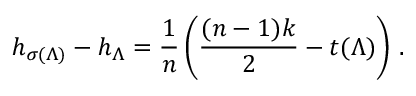Convert formula to latex. <formula><loc_0><loc_0><loc_500><loc_500>h _ { \sigma ( \Lambda ) } - h _ { \Lambda } = \frac { 1 } { n } \left ( \frac { ( n - 1 ) k } 2 - t ( \Lambda ) \right ) \, .</formula> 